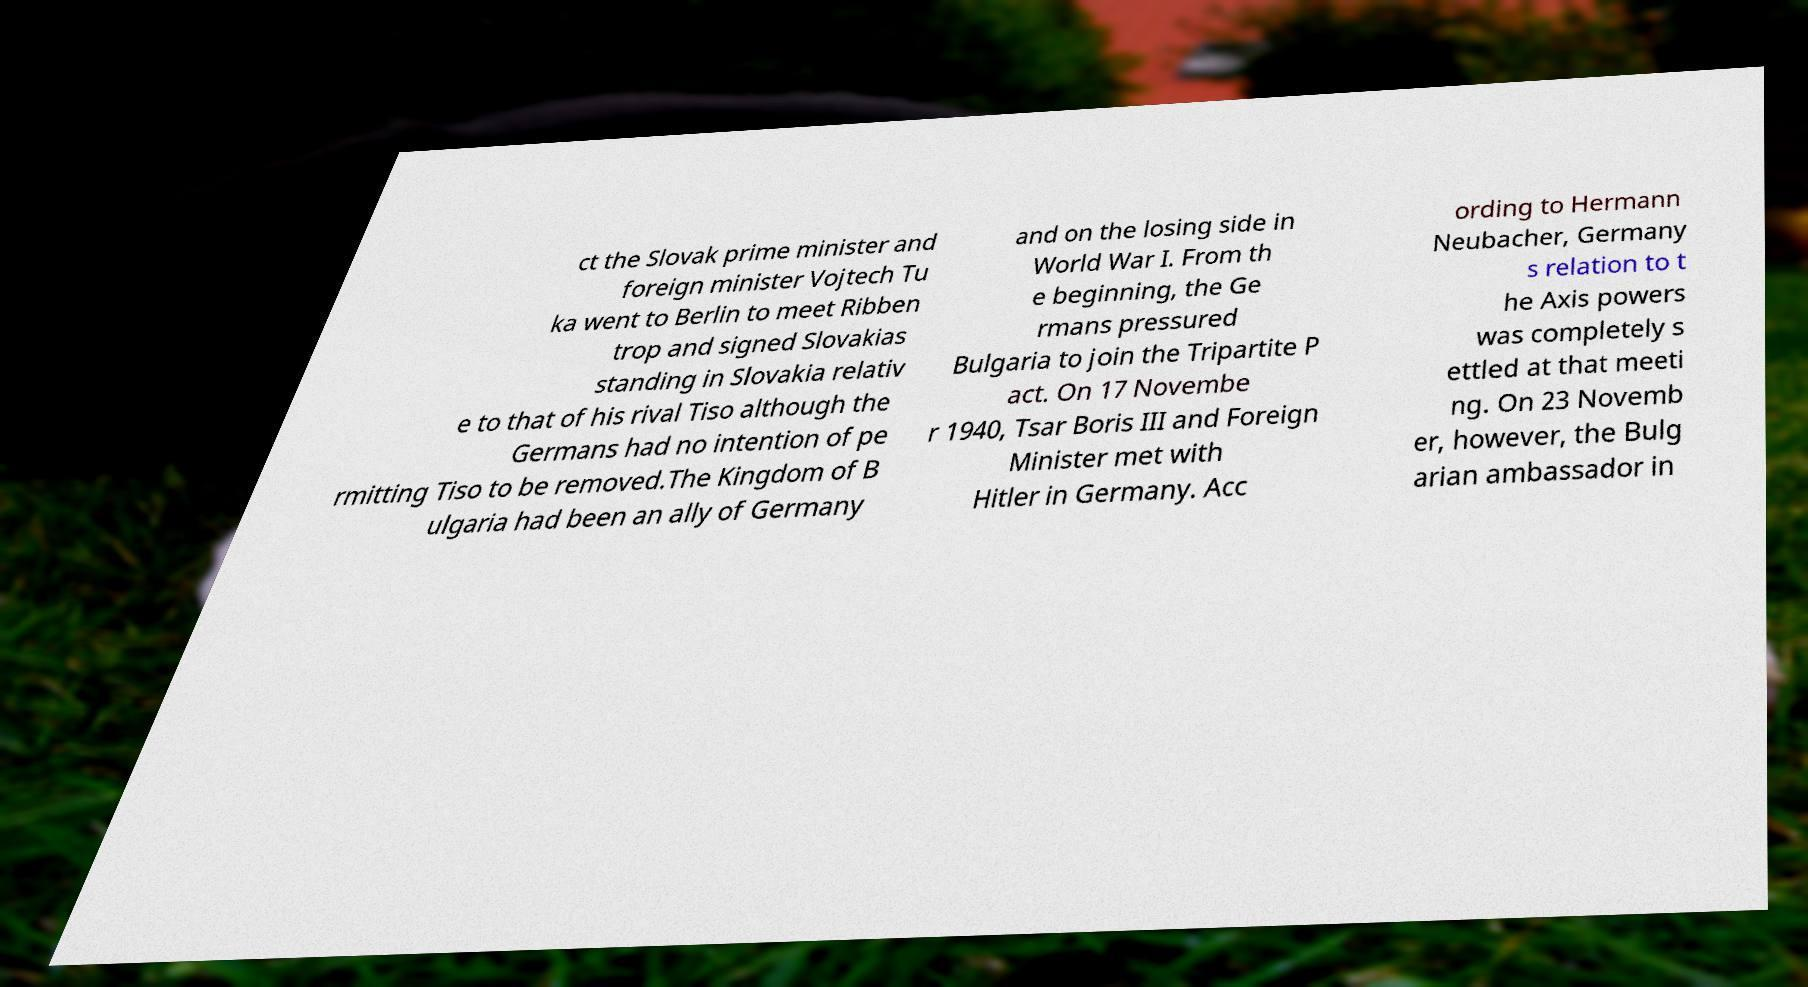Can you accurately transcribe the text from the provided image for me? ct the Slovak prime minister and foreign minister Vojtech Tu ka went to Berlin to meet Ribben trop and signed Slovakias standing in Slovakia relativ e to that of his rival Tiso although the Germans had no intention of pe rmitting Tiso to be removed.The Kingdom of B ulgaria had been an ally of Germany and on the losing side in World War I. From th e beginning, the Ge rmans pressured Bulgaria to join the Tripartite P act. On 17 Novembe r 1940, Tsar Boris III and Foreign Minister met with Hitler in Germany. Acc ording to Hermann Neubacher, Germany s relation to t he Axis powers was completely s ettled at that meeti ng. On 23 Novemb er, however, the Bulg arian ambassador in 